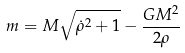Convert formula to latex. <formula><loc_0><loc_0><loc_500><loc_500>m = M \sqrt { \dot { \rho } ^ { 2 } + 1 } - \frac { G M ^ { 2 } } { 2 \rho }</formula> 